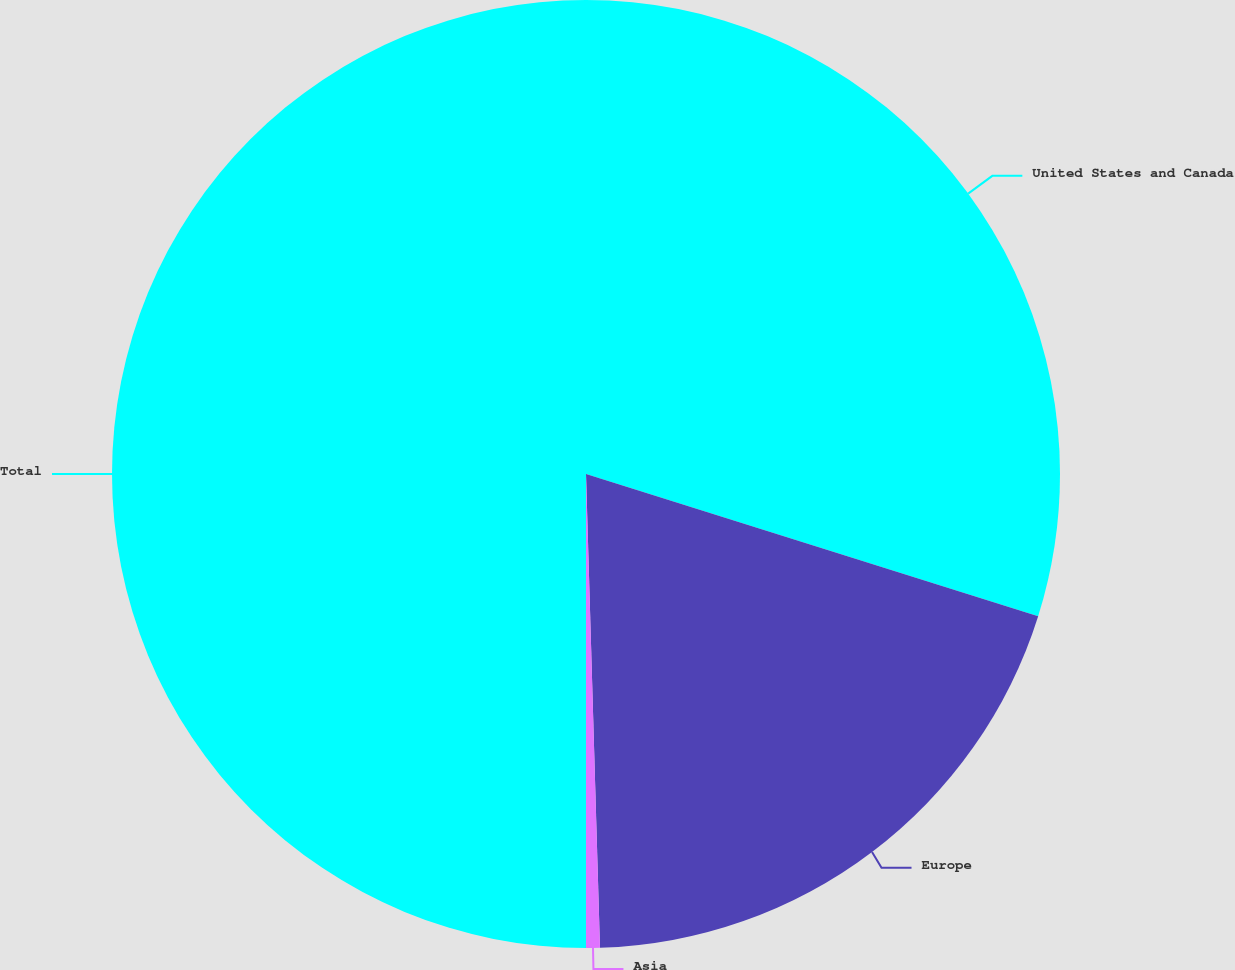Convert chart to OTSL. <chart><loc_0><loc_0><loc_500><loc_500><pie_chart><fcel>United States and Canada<fcel>Europe<fcel>Asia<fcel>Total<nl><fcel>29.85%<fcel>19.68%<fcel>0.47%<fcel>50.0%<nl></chart> 